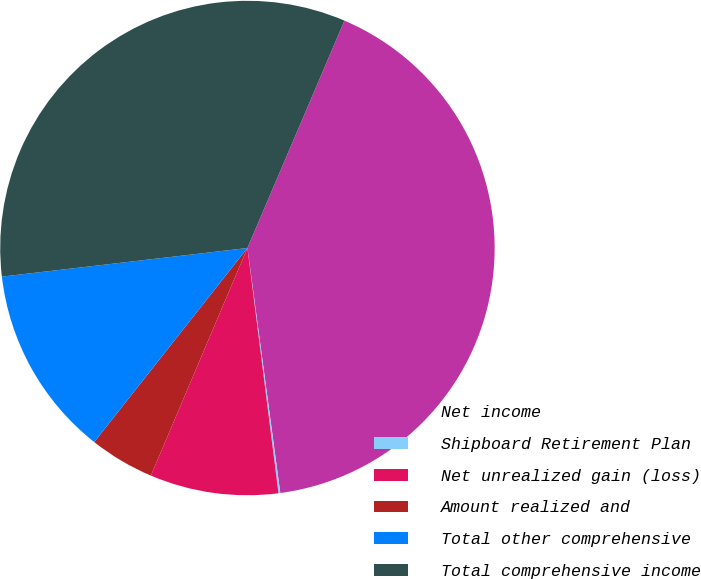Convert chart. <chart><loc_0><loc_0><loc_500><loc_500><pie_chart><fcel>Net income<fcel>Shipboard Retirement Plan<fcel>Net unrealized gain (loss)<fcel>Amount realized and<fcel>Total other comprehensive<fcel>Total comprehensive income<nl><fcel>41.46%<fcel>0.12%<fcel>8.39%<fcel>4.25%<fcel>12.52%<fcel>33.27%<nl></chart> 